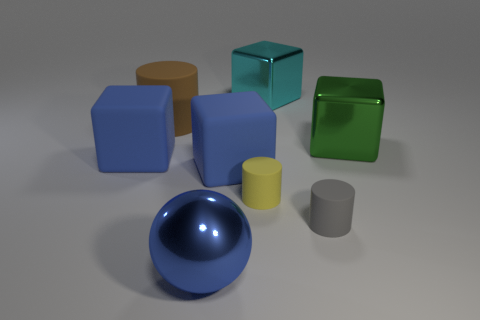Subtract 1 cubes. How many cubes are left? 3 Add 2 small yellow cylinders. How many objects exist? 10 Subtract all spheres. How many objects are left? 7 Subtract 0 brown cubes. How many objects are left? 8 Subtract all tiny matte cylinders. Subtract all blue cubes. How many objects are left? 4 Add 8 metal spheres. How many metal spheres are left? 9 Add 8 tiny gray matte things. How many tiny gray matte things exist? 9 